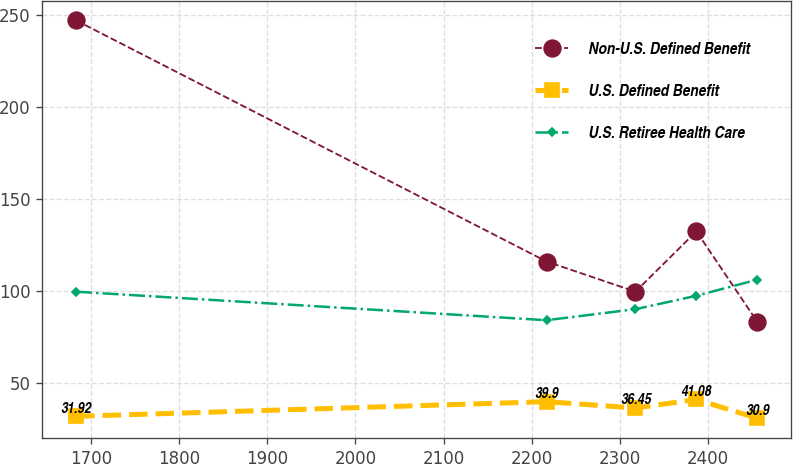Convert chart. <chart><loc_0><loc_0><loc_500><loc_500><line_chart><ecel><fcel>Non-U.S. Defined Benefit<fcel>U.S. Defined Benefit<fcel>U.S. Retiree Health Care<nl><fcel>1683.28<fcel>246.93<fcel>31.92<fcel>99.62<nl><fcel>2216.68<fcel>116.01<fcel>39.9<fcel>84.13<nl><fcel>2317.46<fcel>99.64<fcel>36.45<fcel>90.13<nl><fcel>2386.53<fcel>132.38<fcel>41.08<fcel>97.42<nl><fcel>2455.6<fcel>83.27<fcel>30.9<fcel>106.16<nl></chart> 